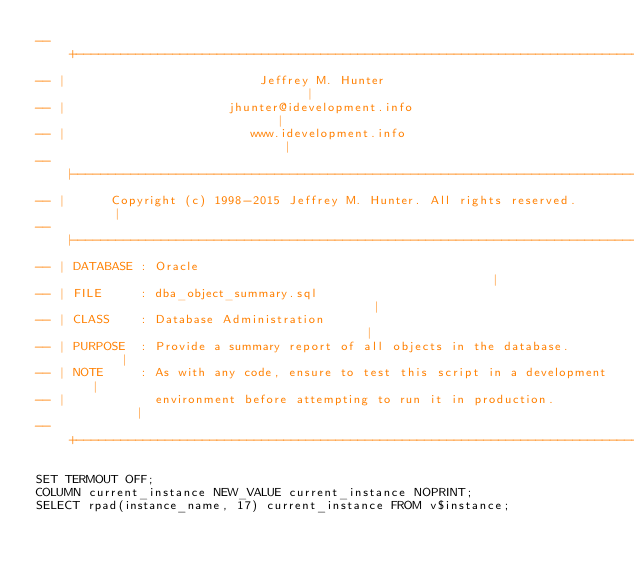<code> <loc_0><loc_0><loc_500><loc_500><_SQL_>-- +----------------------------------------------------------------------------+
-- |                          Jeffrey M. Hunter                                 |
-- |                      jhunter@idevelopment.info                             |
-- |                         www.idevelopment.info                              |
-- |----------------------------------------------------------------------------|
-- |      Copyright (c) 1998-2015 Jeffrey M. Hunter. All rights reserved.       |
-- |----------------------------------------------------------------------------|
-- | DATABASE : Oracle                                                          |
-- | FILE     : dba_object_summary.sql                                          |
-- | CLASS    : Database Administration                                         |
-- | PURPOSE  : Provide a summary report of all objects in the database.        |
-- | NOTE     : As with any code, ensure to test this script in a development   |
-- |            environment before attempting to run it in production.          |
-- +----------------------------------------------------------------------------+

SET TERMOUT OFF;
COLUMN current_instance NEW_VALUE current_instance NOPRINT;
SELECT rpad(instance_name, 17) current_instance FROM v$instance;</code> 